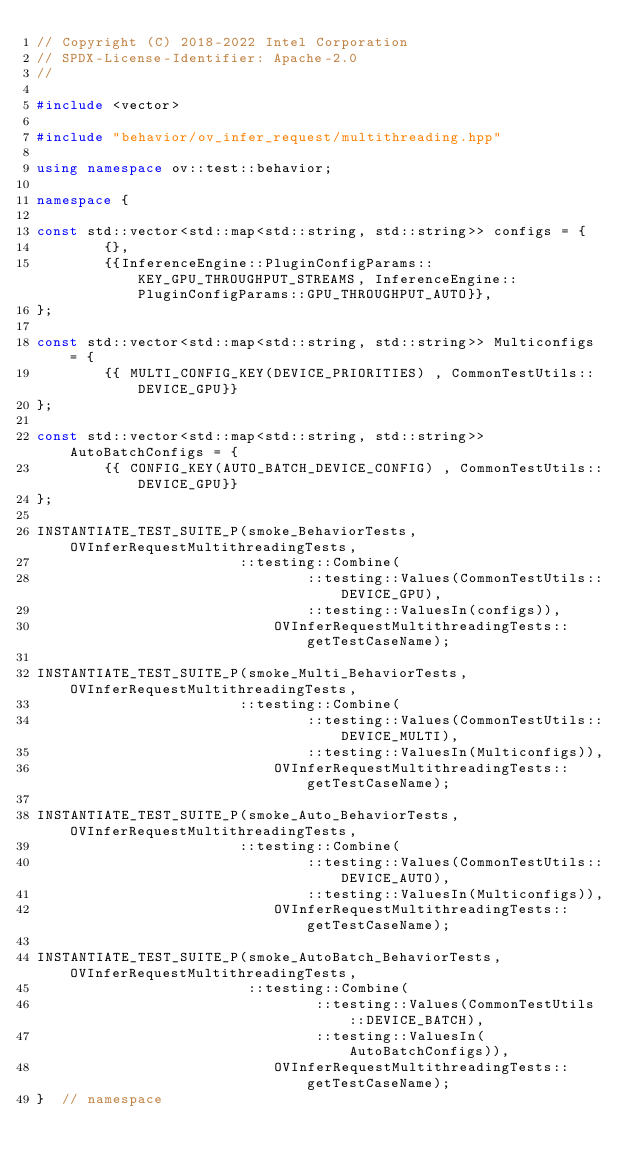Convert code to text. <code><loc_0><loc_0><loc_500><loc_500><_C++_>// Copyright (C) 2018-2022 Intel Corporation
// SPDX-License-Identifier: Apache-2.0
//

#include <vector>

#include "behavior/ov_infer_request/multithreading.hpp"

using namespace ov::test::behavior;

namespace {

const std::vector<std::map<std::string, std::string>> configs = {
        {},
        {{InferenceEngine::PluginConfigParams::KEY_GPU_THROUGHPUT_STREAMS, InferenceEngine::PluginConfigParams::GPU_THROUGHPUT_AUTO}},
};

const std::vector<std::map<std::string, std::string>> Multiconfigs = {
        {{ MULTI_CONFIG_KEY(DEVICE_PRIORITIES) , CommonTestUtils::DEVICE_GPU}}
};

const std::vector<std::map<std::string, std::string>> AutoBatchConfigs = {
        {{ CONFIG_KEY(AUTO_BATCH_DEVICE_CONFIG) , CommonTestUtils::DEVICE_GPU}}
};

INSTANTIATE_TEST_SUITE_P(smoke_BehaviorTests, OVInferRequestMultithreadingTests,
                        ::testing::Combine(
                                ::testing::Values(CommonTestUtils::DEVICE_GPU),
                                ::testing::ValuesIn(configs)),
                            OVInferRequestMultithreadingTests::getTestCaseName);

INSTANTIATE_TEST_SUITE_P(smoke_Multi_BehaviorTests, OVInferRequestMultithreadingTests,
                        ::testing::Combine(
                                ::testing::Values(CommonTestUtils::DEVICE_MULTI),
                                ::testing::ValuesIn(Multiconfigs)),
                            OVInferRequestMultithreadingTests::getTestCaseName);

INSTANTIATE_TEST_SUITE_P(smoke_Auto_BehaviorTests, OVInferRequestMultithreadingTests,
                        ::testing::Combine(
                                ::testing::Values(CommonTestUtils::DEVICE_AUTO),
                                ::testing::ValuesIn(Multiconfigs)),
                            OVInferRequestMultithreadingTests::getTestCaseName);

INSTANTIATE_TEST_SUITE_P(smoke_AutoBatch_BehaviorTests, OVInferRequestMultithreadingTests,
                         ::testing::Combine(
                                 ::testing::Values(CommonTestUtils::DEVICE_BATCH),
                                 ::testing::ValuesIn(AutoBatchConfigs)),
                            OVInferRequestMultithreadingTests::getTestCaseName);
}  // namespace
</code> 